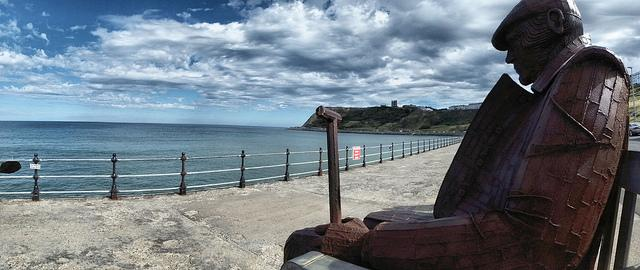What is this man doing? Please explain your reasoning. is resting. The man is resting. 